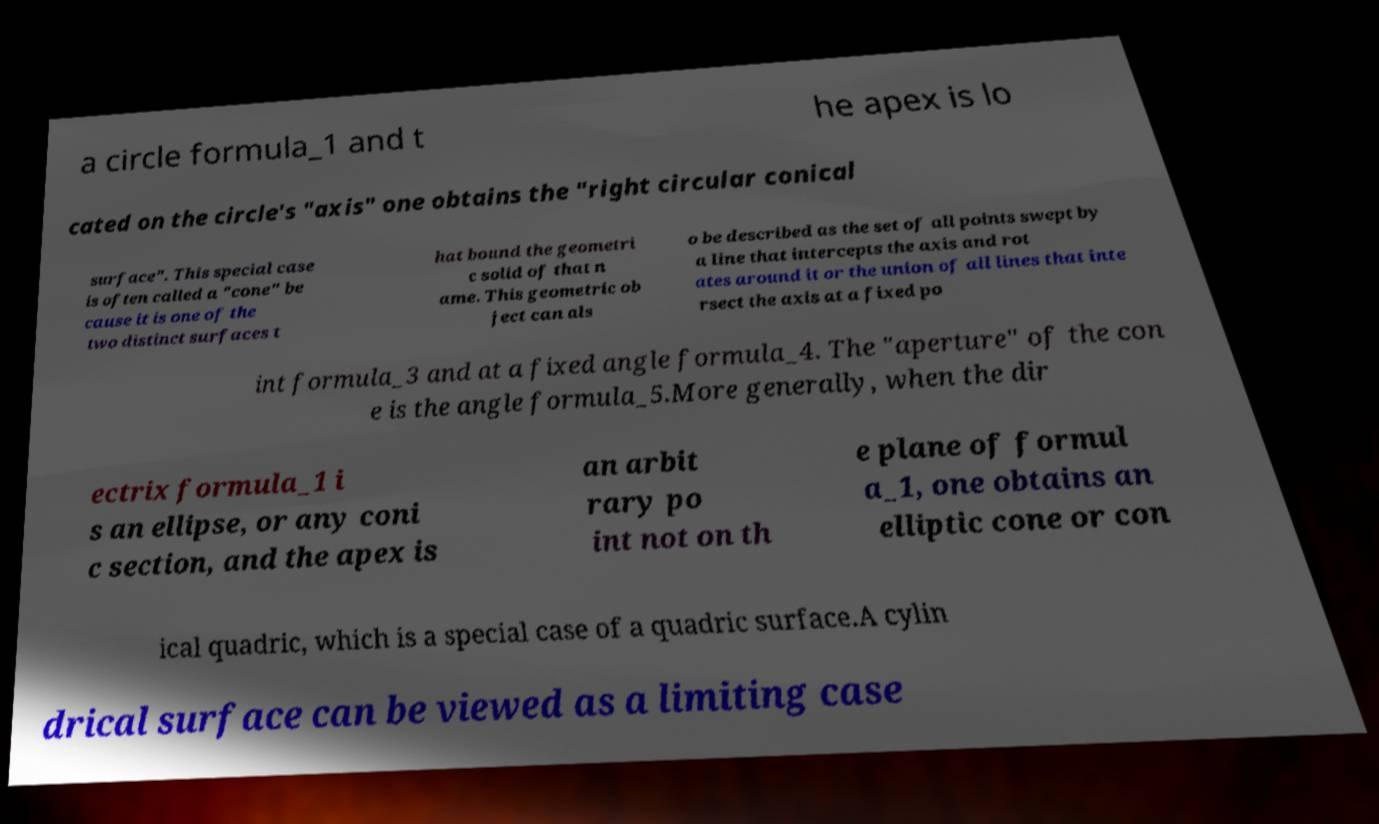Please read and relay the text visible in this image. What does it say? a circle formula_1 and t he apex is lo cated on the circle's "axis" one obtains the "right circular conical surface". This special case is often called a "cone" be cause it is one of the two distinct surfaces t hat bound the geometri c solid of that n ame. This geometric ob ject can als o be described as the set of all points swept by a line that intercepts the axis and rot ates around it or the union of all lines that inte rsect the axis at a fixed po int formula_3 and at a fixed angle formula_4. The "aperture" of the con e is the angle formula_5.More generally, when the dir ectrix formula_1 i s an ellipse, or any coni c section, and the apex is an arbit rary po int not on th e plane of formul a_1, one obtains an elliptic cone or con ical quadric, which is a special case of a quadric surface.A cylin drical surface can be viewed as a limiting case 